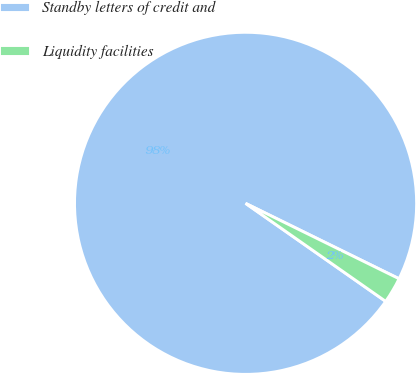Convert chart to OTSL. <chart><loc_0><loc_0><loc_500><loc_500><pie_chart><fcel>Standby letters of credit and<fcel>Liquidity facilities<nl><fcel>97.55%<fcel>2.45%<nl></chart> 